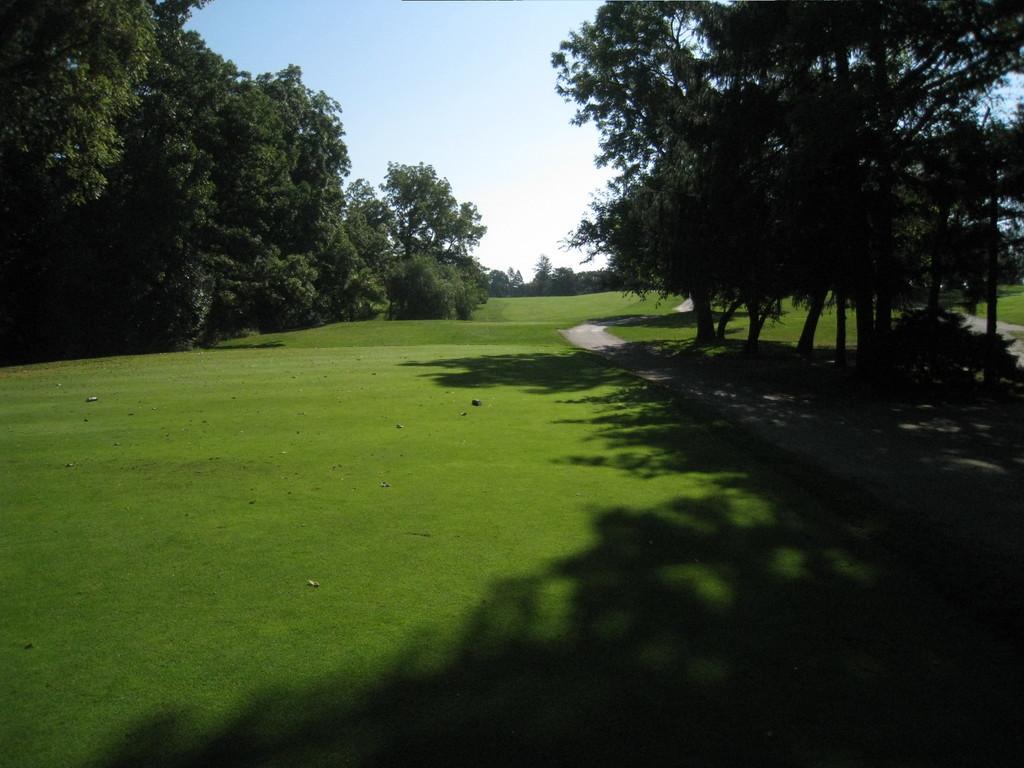Describe this image in one or two sentences. In this picture there is grassland in the center of the image and there are trees on the right and left side of the image, there is a way on the right side of the image. 